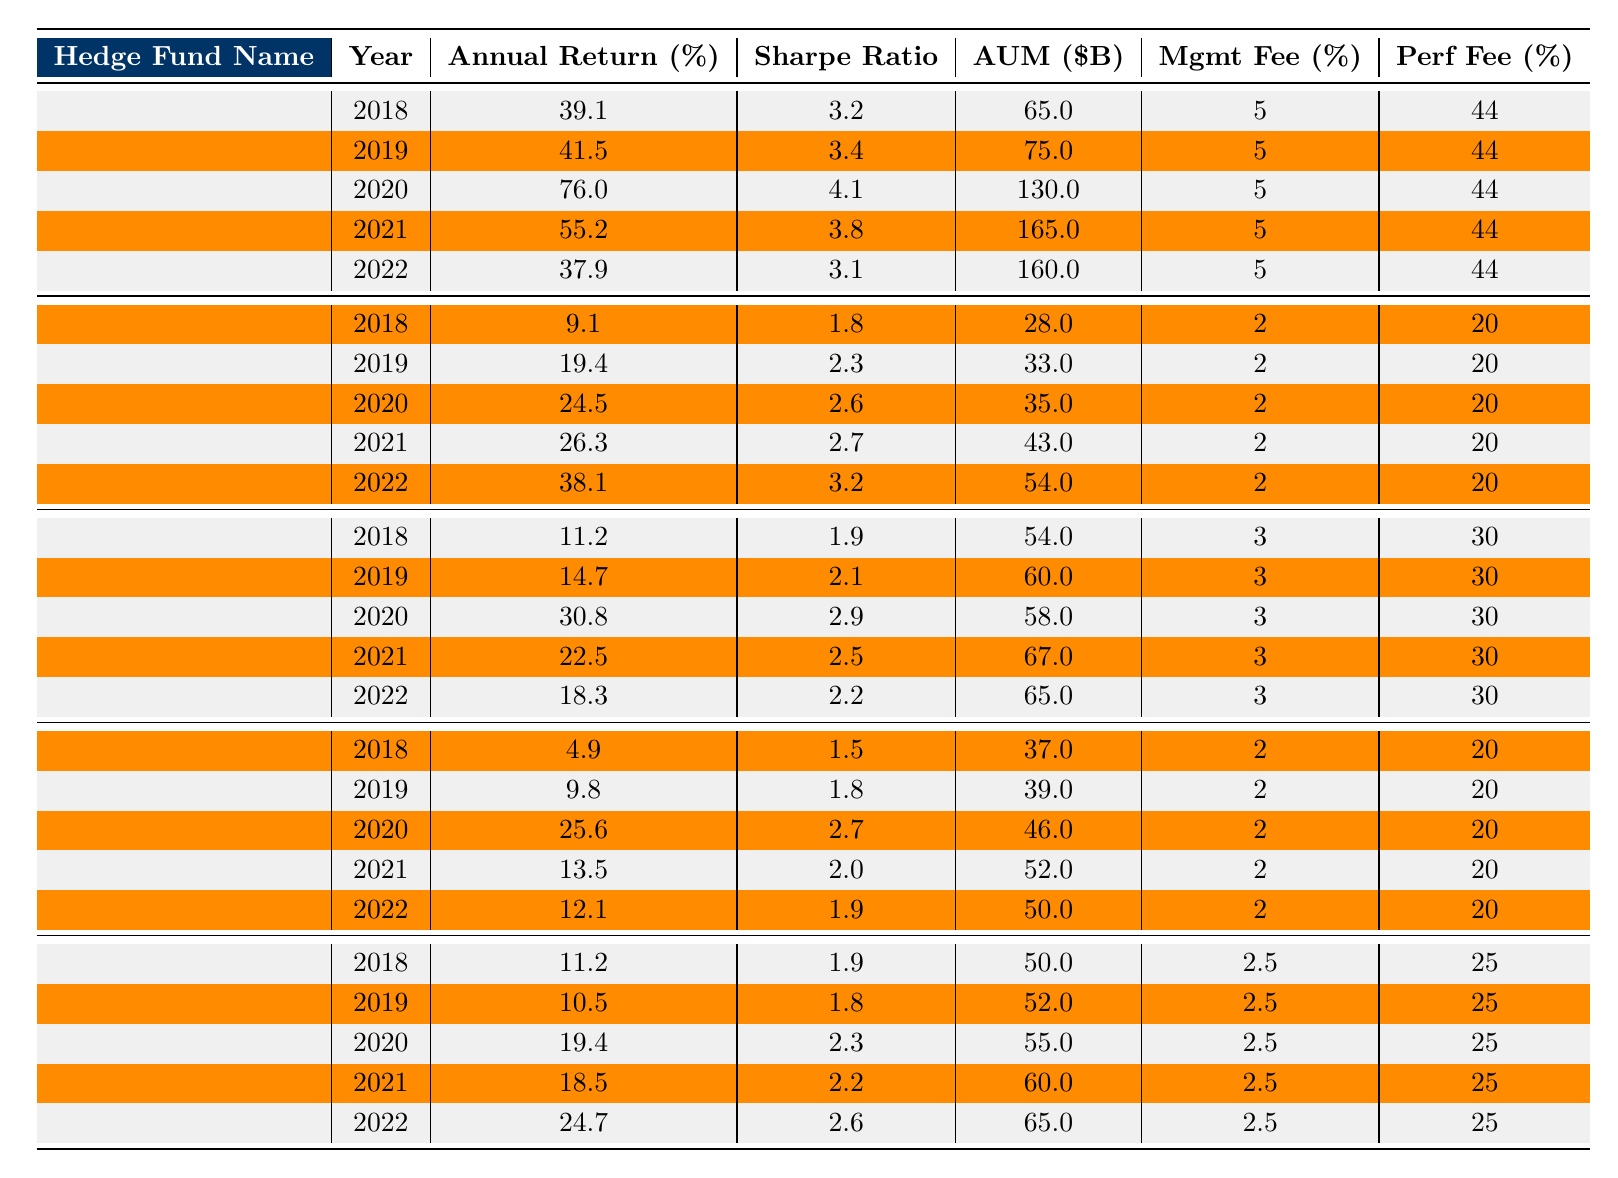What was the highest annual return achieved by Renaissance Technologies over the last five years? The highest annual return for Renaissance Technologies is 76.0%, which occurred in 2020.
Answer: 76.0% What is the average annual return for Citadel over the five years? The annual returns for Citadel are 9.1%, 19.4%, 24.5%, 26.3%, and 38.1%. The sum of these returns is 117.4%. Dividing by 5 gives an average return of 23.48%.
Answer: 23.5% In which year did Two Sigma Investments have its lowest annual return? The lowest annual return for Two Sigma Investments is 11.2%, which occurred in 2018.
Answer: 11.2% What is the Sharpe Ratio of D.E. Shaw & Co. in the year 2021? The Sharpe Ratio of D.E. Shaw & Co. in 2021 is 2.2 as shown in the table.
Answer: 2.2 True or False: Millennium Management had a better annual return than Citadel in 2022. Millennium Management had an annual return of 12.1% in 2022, while Citadel's return was 38.1%. Since 12.1% is less than 38.1%, the statement is false.
Answer: False What is the total Assets Under Management (AUM) for Renaissance Technologies in 2021? The AUM for Renaissance Technologies in 2021 is 165.0 billion dollars, as specified in the table.
Answer: 165.0B Which hedge fund had the highest management fee, and what is its percentage? Renaissance Technologies has the highest management fee of 5% as listed in the table, while the others range from 2% to 3%.
Answer: 5% What is the average performance fee for D.E. Shaw & Co. over the five years? The performance fees for D.E. Shaw & Co. are 25% for all years. The average is thus 25% since they are all the same.
Answer: 25% In which year did Citadel have the highest annual return? Citadel had its highest annual return of 38.1% in 2022.
Answer: 2022 What is the difference in annual returns between Two Sigma Investments in 2020 and Millennium Management in 2020? Two Sigma Investments had an annual return of 30.8% in 2020, while Millennium Management had 25.6%. The difference is 30.8% - 25.6% = 5.2%.
Answer: 5.2% Which fund consistently had the highest annual returns and how many years did it outperform 50%? Renaissance Technologies had the highest returns consistently, with three years (2020, 2021, and 2019) where it outperformed 50%.
Answer: 3 years 